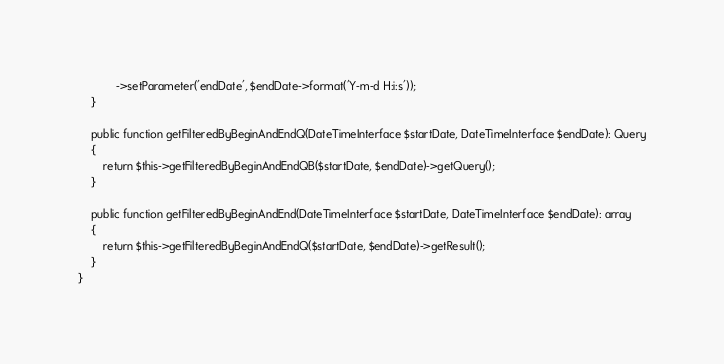<code> <loc_0><loc_0><loc_500><loc_500><_PHP_>            ->setParameter('endDate', $endDate->format('Y-m-d H:i:s'));
    }

    public function getFilteredByBeginAndEndQ(DateTimeInterface $startDate, DateTimeInterface $endDate): Query
    {
        return $this->getFilteredByBeginAndEndQB($startDate, $endDate)->getQuery();
    }

    public function getFilteredByBeginAndEnd(DateTimeInterface $startDate, DateTimeInterface $endDate): array
    {
        return $this->getFilteredByBeginAndEndQ($startDate, $endDate)->getResult();
    }
}
</code> 